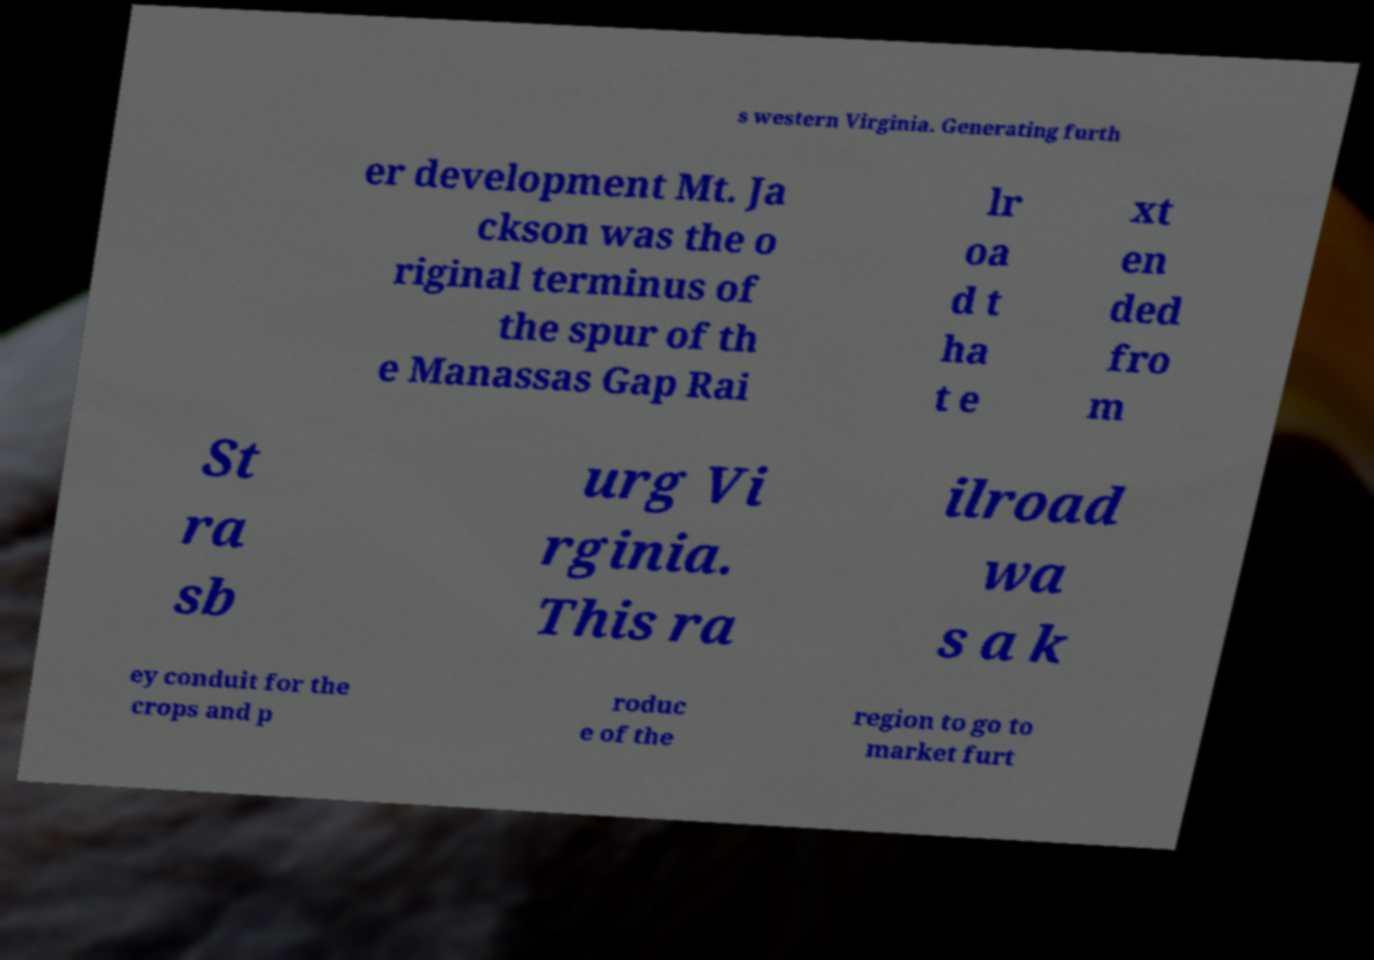Please read and relay the text visible in this image. What does it say? s western Virginia. Generating furth er development Mt. Ja ckson was the o riginal terminus of the spur of th e Manassas Gap Rai lr oa d t ha t e xt en ded fro m St ra sb urg Vi rginia. This ra ilroad wa s a k ey conduit for the crops and p roduc e of the region to go to market furt 